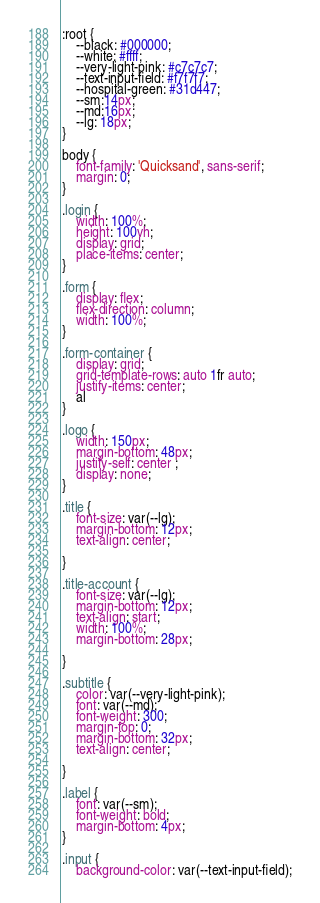<code> <loc_0><loc_0><loc_500><loc_500><_CSS_>:root {
    --black: #000000;
    --white: #ffff;
    --very-light-pink: #c7c7c7;
    --text-input-field: #f7f7f7;
    --hospital-green: #31d447;
    --sm:14px;
    --md:16px;
    --lg: 18px;
}

body {
    font-family: 'Quicksand', sans-serif;
    margin: 0;
}

.login {
    width: 100%;
    height: 100vh;
    display: grid;
    place-items: center;
}

.form {
    display: flex;
    flex-direction: column;
    width: 100%;
}

.form-container {
    display: grid;
    grid-template-rows: auto 1fr auto;
    justify-items: center;
    al
}

.logo {
    width: 150px;
    margin-bottom: 48px;
    justify-self: center ;
    display: none;
}

.title {
    font-size: var(--lg);
    margin-bottom: 12px;
    text-align: center;

}

.title-account {
    font-size: var(--lg);
    margin-bottom: 12px;
    text-align: start;
    width: 100%;
    margin-bottom: 28px;

}

.subtitle {
    color: var(--very-light-pink);
    font: var(--md);
    font-weight: 300;
    margin-top: 0;
    margin-bottom: 32px;
    text-align: center;

}

.label {
    font: var(--sm);
    font-weight: bold;
    margin-bottom: 4px;
}

.input {
    background-color: var(--text-input-field);</code> 